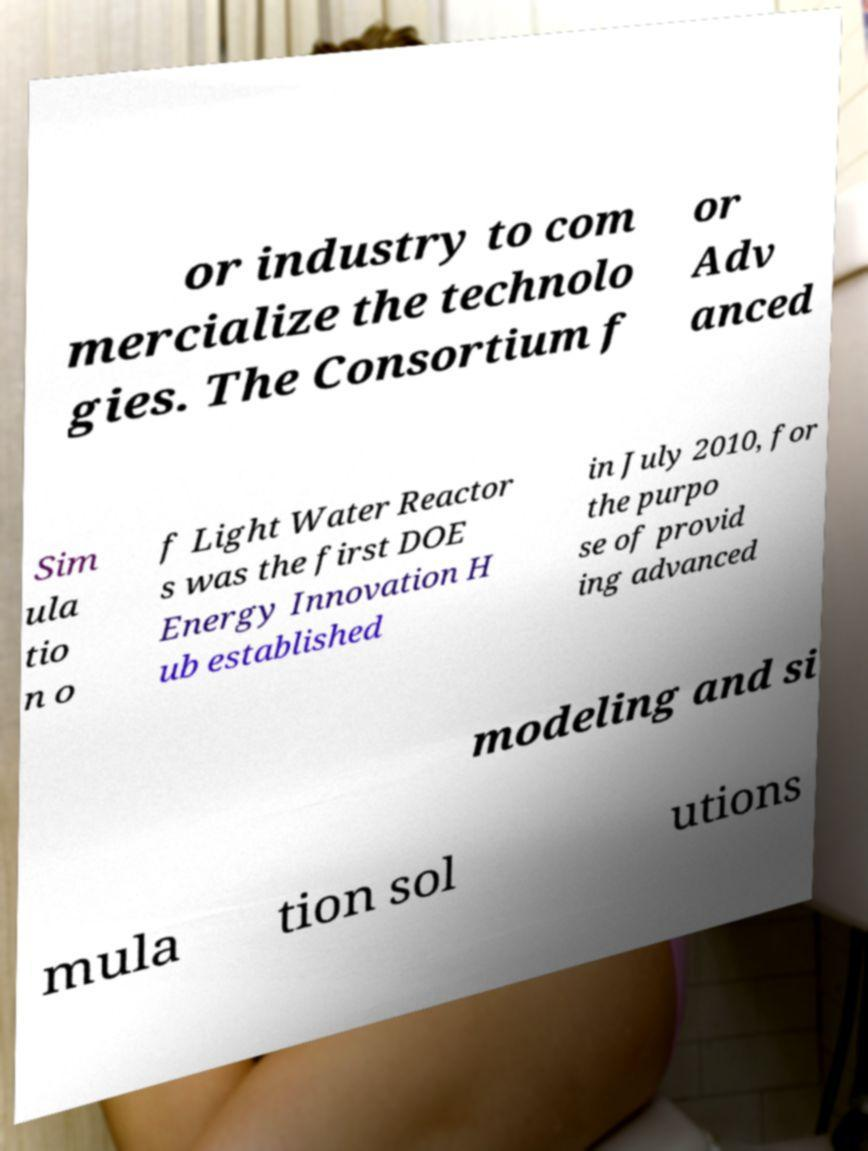Could you extract and type out the text from this image? or industry to com mercialize the technolo gies. The Consortium f or Adv anced Sim ula tio n o f Light Water Reactor s was the first DOE Energy Innovation H ub established in July 2010, for the purpo se of provid ing advanced modeling and si mula tion sol utions 